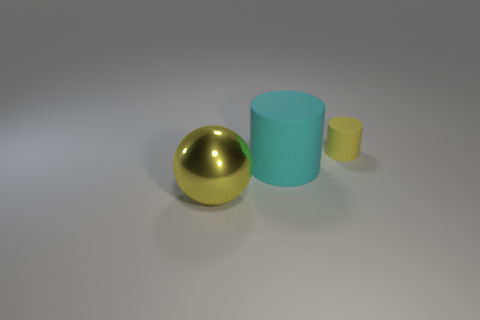Add 3 big shiny objects. How many objects exist? 6 Subtract all balls. How many objects are left? 2 Add 1 small rubber objects. How many small rubber objects exist? 2 Subtract 0 blue balls. How many objects are left? 3 Subtract all large cyan metal objects. Subtract all small things. How many objects are left? 2 Add 2 large cyan matte objects. How many large cyan matte objects are left? 3 